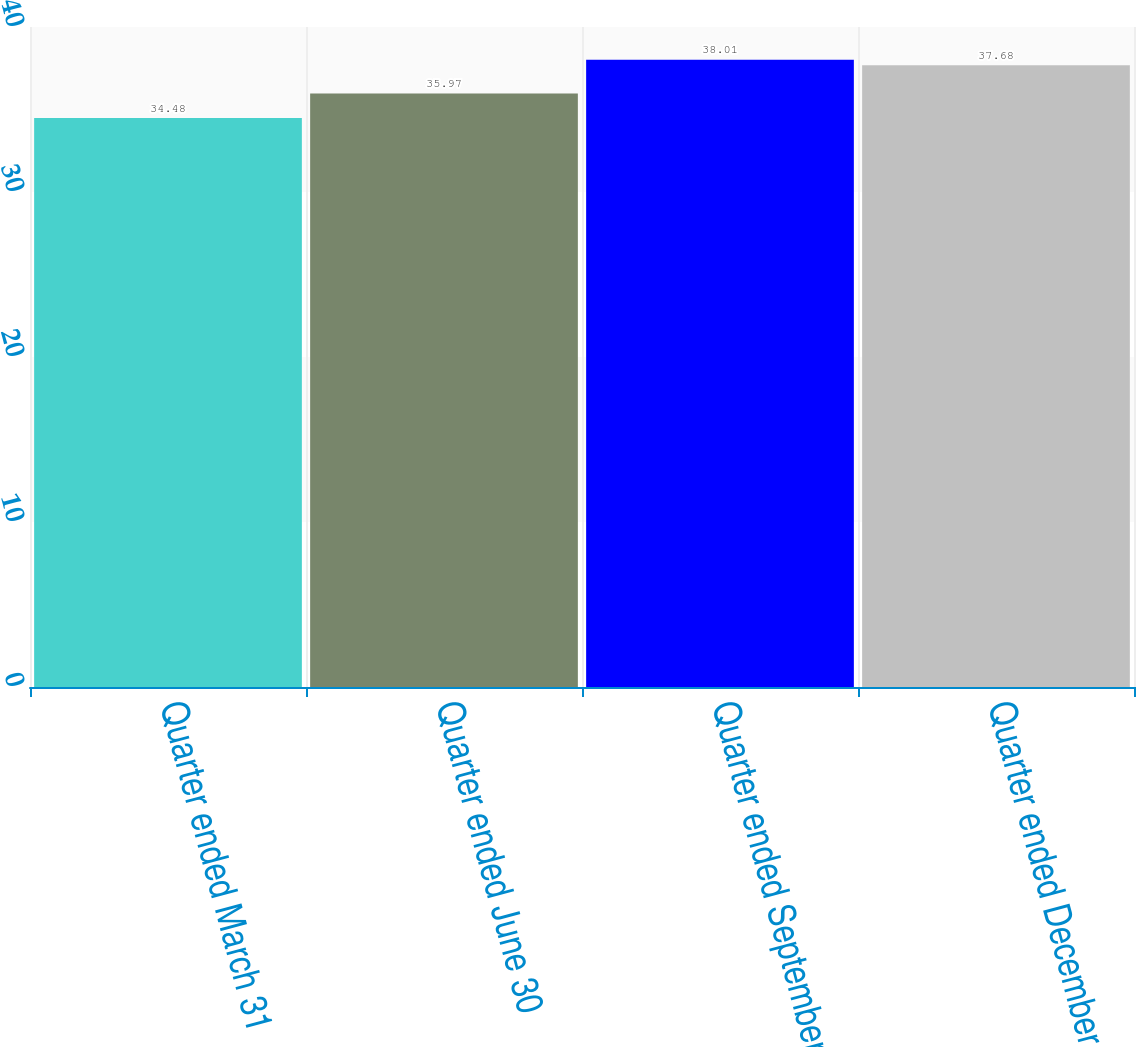Convert chart. <chart><loc_0><loc_0><loc_500><loc_500><bar_chart><fcel>Quarter ended March 31<fcel>Quarter ended June 30<fcel>Quarter ended September 30<fcel>Quarter ended December 31<nl><fcel>34.48<fcel>35.97<fcel>38.01<fcel>37.68<nl></chart> 